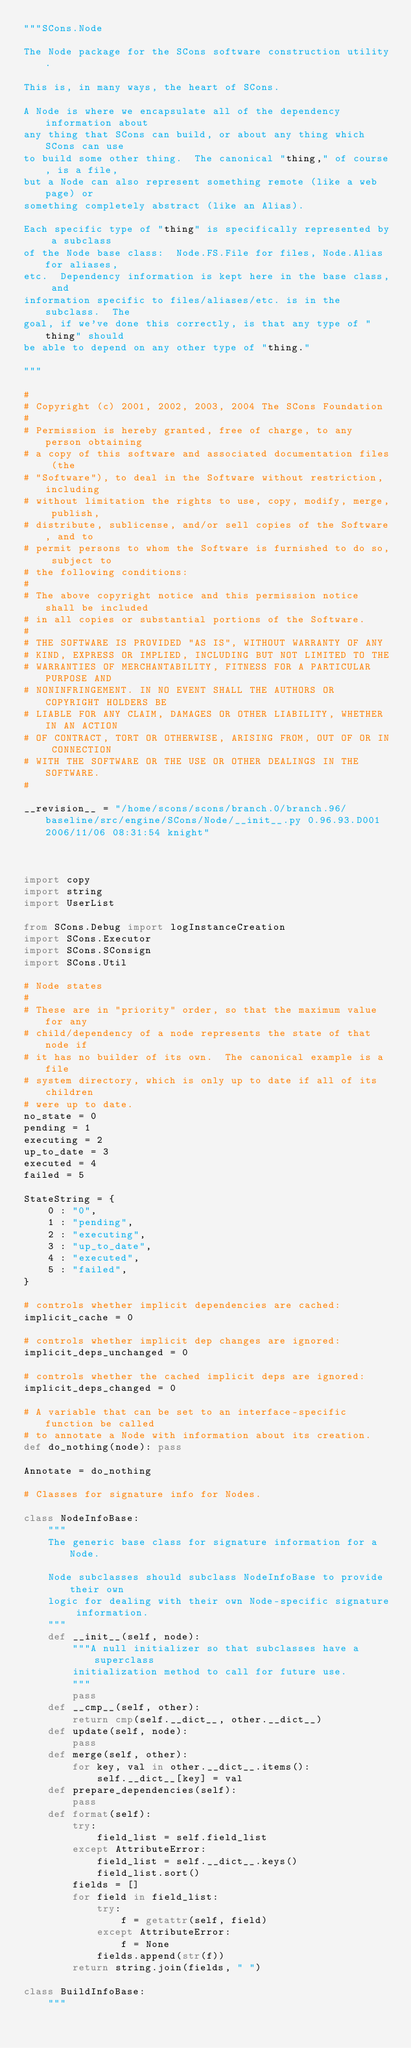<code> <loc_0><loc_0><loc_500><loc_500><_Python_>"""SCons.Node

The Node package for the SCons software construction utility.

This is, in many ways, the heart of SCons.

A Node is where we encapsulate all of the dependency information about
any thing that SCons can build, or about any thing which SCons can use
to build some other thing.  The canonical "thing," of course, is a file,
but a Node can also represent something remote (like a web page) or
something completely abstract (like an Alias).

Each specific type of "thing" is specifically represented by a subclass
of the Node base class:  Node.FS.File for files, Node.Alias for aliases,
etc.  Dependency information is kept here in the base class, and
information specific to files/aliases/etc. is in the subclass.  The
goal, if we've done this correctly, is that any type of "thing" should
be able to depend on any other type of "thing."

"""

#
# Copyright (c) 2001, 2002, 2003, 2004 The SCons Foundation
#
# Permission is hereby granted, free of charge, to any person obtaining
# a copy of this software and associated documentation files (the
# "Software"), to deal in the Software without restriction, including
# without limitation the rights to use, copy, modify, merge, publish,
# distribute, sublicense, and/or sell copies of the Software, and to
# permit persons to whom the Software is furnished to do so, subject to
# the following conditions:
#
# The above copyright notice and this permission notice shall be included
# in all copies or substantial portions of the Software.
#
# THE SOFTWARE IS PROVIDED "AS IS", WITHOUT WARRANTY OF ANY
# KIND, EXPRESS OR IMPLIED, INCLUDING BUT NOT LIMITED TO THE
# WARRANTIES OF MERCHANTABILITY, FITNESS FOR A PARTICULAR PURPOSE AND
# NONINFRINGEMENT. IN NO EVENT SHALL THE AUTHORS OR COPYRIGHT HOLDERS BE
# LIABLE FOR ANY CLAIM, DAMAGES OR OTHER LIABILITY, WHETHER IN AN ACTION
# OF CONTRACT, TORT OR OTHERWISE, ARISING FROM, OUT OF OR IN CONNECTION
# WITH THE SOFTWARE OR THE USE OR OTHER DEALINGS IN THE SOFTWARE.
#

__revision__ = "/home/scons/scons/branch.0/branch.96/baseline/src/engine/SCons/Node/__init__.py 0.96.93.D001 2006/11/06 08:31:54 knight"



import copy
import string
import UserList

from SCons.Debug import logInstanceCreation
import SCons.Executor
import SCons.SConsign
import SCons.Util

# Node states
#
# These are in "priority" order, so that the maximum value for any
# child/dependency of a node represents the state of that node if
# it has no builder of its own.  The canonical example is a file
# system directory, which is only up to date if all of its children
# were up to date.
no_state = 0
pending = 1
executing = 2
up_to_date = 3
executed = 4
failed = 5

StateString = {
    0 : "0",
    1 : "pending",
    2 : "executing",
    3 : "up_to_date",
    4 : "executed",
    5 : "failed",
}

# controls whether implicit dependencies are cached:
implicit_cache = 0

# controls whether implicit dep changes are ignored:
implicit_deps_unchanged = 0

# controls whether the cached implicit deps are ignored:
implicit_deps_changed = 0

# A variable that can be set to an interface-specific function be called
# to annotate a Node with information about its creation.
def do_nothing(node): pass

Annotate = do_nothing

# Classes for signature info for Nodes.

class NodeInfoBase:
    """
    The generic base class for signature information for a Node.

    Node subclasses should subclass NodeInfoBase to provide their own
    logic for dealing with their own Node-specific signature information.
    """
    def __init__(self, node):
        """A null initializer so that subclasses have a superclass
        initialization method to call for future use.
        """
        pass
    def __cmp__(self, other):
        return cmp(self.__dict__, other.__dict__)
    def update(self, node):
        pass
    def merge(self, other):
        for key, val in other.__dict__.items():
            self.__dict__[key] = val
    def prepare_dependencies(self):
        pass
    def format(self):
        try:
            field_list = self.field_list
        except AttributeError:
            field_list = self.__dict__.keys()
            field_list.sort()
        fields = []
        for field in field_list:
            try:
                f = getattr(self, field)
            except AttributeError:
                f = None
            fields.append(str(f))
        return string.join(fields, " ")

class BuildInfoBase:
    """</code> 